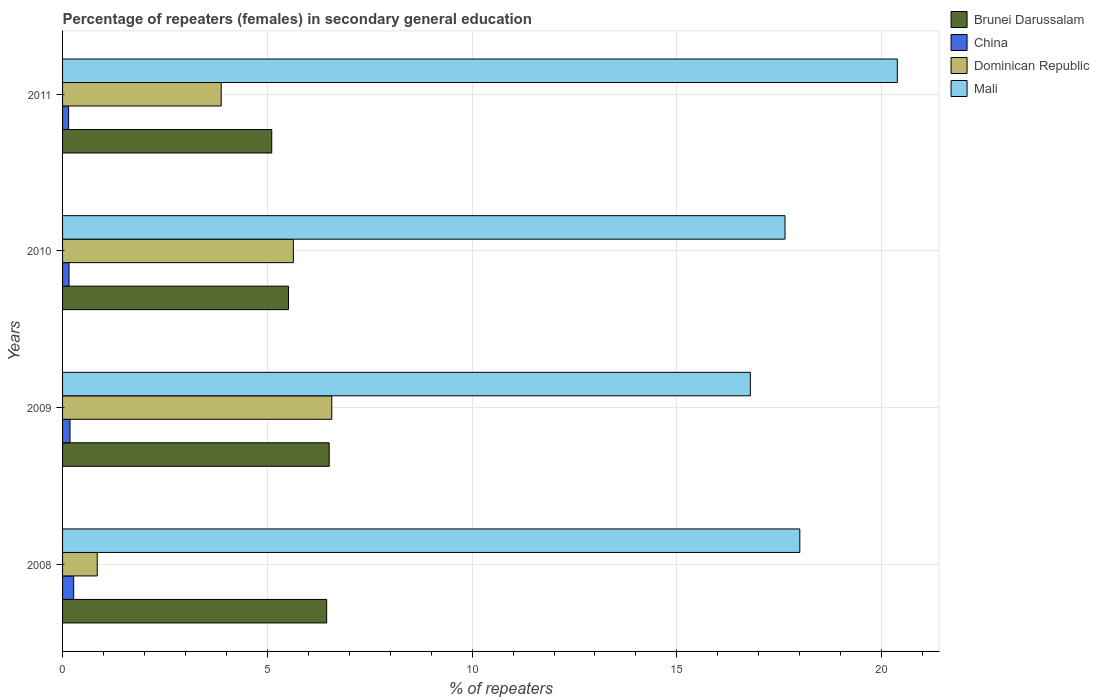How many groups of bars are there?
Your answer should be very brief. 4. What is the label of the 1st group of bars from the top?
Keep it short and to the point. 2011. What is the percentage of female repeaters in Brunei Darussalam in 2010?
Ensure brevity in your answer.  5.52. Across all years, what is the maximum percentage of female repeaters in Brunei Darussalam?
Your answer should be compact. 6.51. Across all years, what is the minimum percentage of female repeaters in Mali?
Your answer should be very brief. 16.79. In which year was the percentage of female repeaters in Dominican Republic maximum?
Your response must be concise. 2009. What is the total percentage of female repeaters in Brunei Darussalam in the graph?
Make the answer very short. 23.58. What is the difference between the percentage of female repeaters in Dominican Republic in 2008 and that in 2011?
Your answer should be very brief. -3.03. What is the difference between the percentage of female repeaters in Mali in 2009 and the percentage of female repeaters in Brunei Darussalam in 2011?
Give a very brief answer. 11.69. What is the average percentage of female repeaters in Dominican Republic per year?
Keep it short and to the point. 4.23. In the year 2011, what is the difference between the percentage of female repeaters in Dominican Republic and percentage of female repeaters in China?
Provide a short and direct response. 3.73. In how many years, is the percentage of female repeaters in China greater than 3 %?
Provide a succinct answer. 0. What is the ratio of the percentage of female repeaters in Mali in 2008 to that in 2010?
Ensure brevity in your answer.  1.02. Is the percentage of female repeaters in China in 2008 less than that in 2009?
Give a very brief answer. No. What is the difference between the highest and the second highest percentage of female repeaters in China?
Give a very brief answer. 0.09. What is the difference between the highest and the lowest percentage of female repeaters in Mali?
Keep it short and to the point. 3.59. In how many years, is the percentage of female repeaters in Mali greater than the average percentage of female repeaters in Mali taken over all years?
Provide a succinct answer. 1. Is the sum of the percentage of female repeaters in Dominican Republic in 2008 and 2010 greater than the maximum percentage of female repeaters in Mali across all years?
Provide a succinct answer. No. Is it the case that in every year, the sum of the percentage of female repeaters in China and percentage of female repeaters in Mali is greater than the sum of percentage of female repeaters in Brunei Darussalam and percentage of female repeaters in Dominican Republic?
Your answer should be very brief. Yes. What does the 4th bar from the top in 2009 represents?
Ensure brevity in your answer.  Brunei Darussalam. What does the 1st bar from the bottom in 2009 represents?
Your answer should be compact. Brunei Darussalam. Is it the case that in every year, the sum of the percentage of female repeaters in Mali and percentage of female repeaters in Dominican Republic is greater than the percentage of female repeaters in Brunei Darussalam?
Your response must be concise. Yes. How many bars are there?
Offer a terse response. 16. Are all the bars in the graph horizontal?
Provide a short and direct response. Yes. Are the values on the major ticks of X-axis written in scientific E-notation?
Your response must be concise. No. Does the graph contain grids?
Offer a terse response. Yes. Where does the legend appear in the graph?
Your response must be concise. Top right. What is the title of the graph?
Give a very brief answer. Percentage of repeaters (females) in secondary general education. Does "Marshall Islands" appear as one of the legend labels in the graph?
Give a very brief answer. No. What is the label or title of the X-axis?
Give a very brief answer. % of repeaters. What is the label or title of the Y-axis?
Make the answer very short. Years. What is the % of repeaters in Brunei Darussalam in 2008?
Offer a very short reply. 6.45. What is the % of repeaters in China in 2008?
Make the answer very short. 0.27. What is the % of repeaters of Dominican Republic in 2008?
Your answer should be very brief. 0.85. What is the % of repeaters in Mali in 2008?
Make the answer very short. 18. What is the % of repeaters of Brunei Darussalam in 2009?
Offer a terse response. 6.51. What is the % of repeaters of China in 2009?
Keep it short and to the point. 0.18. What is the % of repeaters of Dominican Republic in 2009?
Provide a succinct answer. 6.57. What is the % of repeaters in Mali in 2009?
Provide a succinct answer. 16.79. What is the % of repeaters in Brunei Darussalam in 2010?
Ensure brevity in your answer.  5.52. What is the % of repeaters of China in 2010?
Make the answer very short. 0.16. What is the % of repeaters in Dominican Republic in 2010?
Make the answer very short. 5.64. What is the % of repeaters in Mali in 2010?
Offer a terse response. 17.64. What is the % of repeaters in Brunei Darussalam in 2011?
Provide a short and direct response. 5.11. What is the % of repeaters of China in 2011?
Ensure brevity in your answer.  0.15. What is the % of repeaters of Dominican Republic in 2011?
Your answer should be compact. 3.87. What is the % of repeaters in Mali in 2011?
Ensure brevity in your answer.  20.38. Across all years, what is the maximum % of repeaters in Brunei Darussalam?
Make the answer very short. 6.51. Across all years, what is the maximum % of repeaters of China?
Provide a succinct answer. 0.27. Across all years, what is the maximum % of repeaters in Dominican Republic?
Your answer should be compact. 6.57. Across all years, what is the maximum % of repeaters of Mali?
Your response must be concise. 20.38. Across all years, what is the minimum % of repeaters in Brunei Darussalam?
Offer a very short reply. 5.11. Across all years, what is the minimum % of repeaters in China?
Give a very brief answer. 0.15. Across all years, what is the minimum % of repeaters of Dominican Republic?
Offer a terse response. 0.85. Across all years, what is the minimum % of repeaters of Mali?
Offer a terse response. 16.79. What is the total % of repeaters in Brunei Darussalam in the graph?
Give a very brief answer. 23.58. What is the total % of repeaters in China in the graph?
Your answer should be compact. 0.76. What is the total % of repeaters of Dominican Republic in the graph?
Offer a terse response. 16.93. What is the total % of repeaters of Mali in the graph?
Your response must be concise. 72.82. What is the difference between the % of repeaters in Brunei Darussalam in 2008 and that in 2009?
Keep it short and to the point. -0.06. What is the difference between the % of repeaters of China in 2008 and that in 2009?
Keep it short and to the point. 0.09. What is the difference between the % of repeaters in Dominican Republic in 2008 and that in 2009?
Your response must be concise. -5.73. What is the difference between the % of repeaters of Mali in 2008 and that in 2009?
Provide a short and direct response. 1.21. What is the difference between the % of repeaters of Brunei Darussalam in 2008 and that in 2010?
Your answer should be very brief. 0.93. What is the difference between the % of repeaters of China in 2008 and that in 2010?
Give a very brief answer. 0.11. What is the difference between the % of repeaters in Dominican Republic in 2008 and that in 2010?
Give a very brief answer. -4.79. What is the difference between the % of repeaters of Mali in 2008 and that in 2010?
Keep it short and to the point. 0.36. What is the difference between the % of repeaters of Brunei Darussalam in 2008 and that in 2011?
Make the answer very short. 1.34. What is the difference between the % of repeaters in China in 2008 and that in 2011?
Provide a succinct answer. 0.12. What is the difference between the % of repeaters in Dominican Republic in 2008 and that in 2011?
Ensure brevity in your answer.  -3.03. What is the difference between the % of repeaters of Mali in 2008 and that in 2011?
Keep it short and to the point. -2.38. What is the difference between the % of repeaters in China in 2009 and that in 2010?
Your response must be concise. 0.02. What is the difference between the % of repeaters in Dominican Republic in 2009 and that in 2010?
Keep it short and to the point. 0.94. What is the difference between the % of repeaters of Mali in 2009 and that in 2010?
Give a very brief answer. -0.85. What is the difference between the % of repeaters of Brunei Darussalam in 2009 and that in 2011?
Provide a short and direct response. 1.4. What is the difference between the % of repeaters in China in 2009 and that in 2011?
Your answer should be very brief. 0.03. What is the difference between the % of repeaters in Dominican Republic in 2009 and that in 2011?
Offer a very short reply. 2.7. What is the difference between the % of repeaters in Mali in 2009 and that in 2011?
Your answer should be compact. -3.59. What is the difference between the % of repeaters in Brunei Darussalam in 2010 and that in 2011?
Make the answer very short. 0.41. What is the difference between the % of repeaters in China in 2010 and that in 2011?
Your answer should be very brief. 0.01. What is the difference between the % of repeaters of Dominican Republic in 2010 and that in 2011?
Make the answer very short. 1.76. What is the difference between the % of repeaters of Mali in 2010 and that in 2011?
Keep it short and to the point. -2.74. What is the difference between the % of repeaters of Brunei Darussalam in 2008 and the % of repeaters of China in 2009?
Ensure brevity in your answer.  6.27. What is the difference between the % of repeaters in Brunei Darussalam in 2008 and the % of repeaters in Dominican Republic in 2009?
Your response must be concise. -0.13. What is the difference between the % of repeaters in Brunei Darussalam in 2008 and the % of repeaters in Mali in 2009?
Ensure brevity in your answer.  -10.35. What is the difference between the % of repeaters of China in 2008 and the % of repeaters of Dominican Republic in 2009?
Provide a succinct answer. -6.3. What is the difference between the % of repeaters of China in 2008 and the % of repeaters of Mali in 2009?
Make the answer very short. -16.52. What is the difference between the % of repeaters of Dominican Republic in 2008 and the % of repeaters of Mali in 2009?
Provide a succinct answer. -15.95. What is the difference between the % of repeaters in Brunei Darussalam in 2008 and the % of repeaters in China in 2010?
Give a very brief answer. 6.29. What is the difference between the % of repeaters in Brunei Darussalam in 2008 and the % of repeaters in Dominican Republic in 2010?
Provide a short and direct response. 0.81. What is the difference between the % of repeaters of Brunei Darussalam in 2008 and the % of repeaters of Mali in 2010?
Give a very brief answer. -11.19. What is the difference between the % of repeaters in China in 2008 and the % of repeaters in Dominican Republic in 2010?
Offer a terse response. -5.36. What is the difference between the % of repeaters in China in 2008 and the % of repeaters in Mali in 2010?
Your answer should be compact. -17.37. What is the difference between the % of repeaters in Dominican Republic in 2008 and the % of repeaters in Mali in 2010?
Make the answer very short. -16.79. What is the difference between the % of repeaters of Brunei Darussalam in 2008 and the % of repeaters of China in 2011?
Give a very brief answer. 6.3. What is the difference between the % of repeaters of Brunei Darussalam in 2008 and the % of repeaters of Dominican Republic in 2011?
Offer a terse response. 2.58. What is the difference between the % of repeaters in Brunei Darussalam in 2008 and the % of repeaters in Mali in 2011?
Give a very brief answer. -13.93. What is the difference between the % of repeaters of China in 2008 and the % of repeaters of Dominican Republic in 2011?
Make the answer very short. -3.6. What is the difference between the % of repeaters in China in 2008 and the % of repeaters in Mali in 2011?
Offer a very short reply. -20.11. What is the difference between the % of repeaters of Dominican Republic in 2008 and the % of repeaters of Mali in 2011?
Your answer should be very brief. -19.54. What is the difference between the % of repeaters in Brunei Darussalam in 2009 and the % of repeaters in China in 2010?
Provide a succinct answer. 6.35. What is the difference between the % of repeaters in Brunei Darussalam in 2009 and the % of repeaters in Dominican Republic in 2010?
Keep it short and to the point. 0.88. What is the difference between the % of repeaters in Brunei Darussalam in 2009 and the % of repeaters in Mali in 2010?
Your response must be concise. -11.13. What is the difference between the % of repeaters of China in 2009 and the % of repeaters of Dominican Republic in 2010?
Give a very brief answer. -5.45. What is the difference between the % of repeaters in China in 2009 and the % of repeaters in Mali in 2010?
Provide a succinct answer. -17.46. What is the difference between the % of repeaters in Dominican Republic in 2009 and the % of repeaters in Mali in 2010?
Offer a very short reply. -11.07. What is the difference between the % of repeaters in Brunei Darussalam in 2009 and the % of repeaters in China in 2011?
Make the answer very short. 6.36. What is the difference between the % of repeaters of Brunei Darussalam in 2009 and the % of repeaters of Dominican Republic in 2011?
Offer a terse response. 2.64. What is the difference between the % of repeaters in Brunei Darussalam in 2009 and the % of repeaters in Mali in 2011?
Provide a short and direct response. -13.87. What is the difference between the % of repeaters of China in 2009 and the % of repeaters of Dominican Republic in 2011?
Offer a terse response. -3.69. What is the difference between the % of repeaters in China in 2009 and the % of repeaters in Mali in 2011?
Make the answer very short. -20.2. What is the difference between the % of repeaters of Dominican Republic in 2009 and the % of repeaters of Mali in 2011?
Ensure brevity in your answer.  -13.81. What is the difference between the % of repeaters of Brunei Darussalam in 2010 and the % of repeaters of China in 2011?
Provide a short and direct response. 5.37. What is the difference between the % of repeaters of Brunei Darussalam in 2010 and the % of repeaters of Dominican Republic in 2011?
Ensure brevity in your answer.  1.64. What is the difference between the % of repeaters of Brunei Darussalam in 2010 and the % of repeaters of Mali in 2011?
Your answer should be compact. -14.87. What is the difference between the % of repeaters in China in 2010 and the % of repeaters in Dominican Republic in 2011?
Offer a terse response. -3.72. What is the difference between the % of repeaters of China in 2010 and the % of repeaters of Mali in 2011?
Your answer should be very brief. -20.22. What is the difference between the % of repeaters of Dominican Republic in 2010 and the % of repeaters of Mali in 2011?
Provide a succinct answer. -14.75. What is the average % of repeaters of Brunei Darussalam per year?
Your response must be concise. 5.9. What is the average % of repeaters of China per year?
Ensure brevity in your answer.  0.19. What is the average % of repeaters in Dominican Republic per year?
Make the answer very short. 4.23. What is the average % of repeaters in Mali per year?
Offer a very short reply. 18.2. In the year 2008, what is the difference between the % of repeaters of Brunei Darussalam and % of repeaters of China?
Make the answer very short. 6.18. In the year 2008, what is the difference between the % of repeaters of Brunei Darussalam and % of repeaters of Dominican Republic?
Provide a short and direct response. 5.6. In the year 2008, what is the difference between the % of repeaters of Brunei Darussalam and % of repeaters of Mali?
Offer a terse response. -11.55. In the year 2008, what is the difference between the % of repeaters in China and % of repeaters in Dominican Republic?
Your response must be concise. -0.58. In the year 2008, what is the difference between the % of repeaters of China and % of repeaters of Mali?
Your answer should be compact. -17.73. In the year 2008, what is the difference between the % of repeaters of Dominican Republic and % of repeaters of Mali?
Ensure brevity in your answer.  -17.16. In the year 2009, what is the difference between the % of repeaters of Brunei Darussalam and % of repeaters of China?
Your response must be concise. 6.33. In the year 2009, what is the difference between the % of repeaters in Brunei Darussalam and % of repeaters in Dominican Republic?
Offer a terse response. -0.06. In the year 2009, what is the difference between the % of repeaters in Brunei Darussalam and % of repeaters in Mali?
Provide a short and direct response. -10.28. In the year 2009, what is the difference between the % of repeaters in China and % of repeaters in Dominican Republic?
Your answer should be compact. -6.39. In the year 2009, what is the difference between the % of repeaters of China and % of repeaters of Mali?
Provide a succinct answer. -16.61. In the year 2009, what is the difference between the % of repeaters of Dominican Republic and % of repeaters of Mali?
Your answer should be compact. -10.22. In the year 2010, what is the difference between the % of repeaters of Brunei Darussalam and % of repeaters of China?
Give a very brief answer. 5.36. In the year 2010, what is the difference between the % of repeaters of Brunei Darussalam and % of repeaters of Dominican Republic?
Your answer should be very brief. -0.12. In the year 2010, what is the difference between the % of repeaters in Brunei Darussalam and % of repeaters in Mali?
Your response must be concise. -12.12. In the year 2010, what is the difference between the % of repeaters of China and % of repeaters of Dominican Republic?
Your answer should be compact. -5.48. In the year 2010, what is the difference between the % of repeaters of China and % of repeaters of Mali?
Offer a terse response. -17.48. In the year 2010, what is the difference between the % of repeaters in Dominican Republic and % of repeaters in Mali?
Make the answer very short. -12. In the year 2011, what is the difference between the % of repeaters in Brunei Darussalam and % of repeaters in China?
Provide a succinct answer. 4.96. In the year 2011, what is the difference between the % of repeaters of Brunei Darussalam and % of repeaters of Dominican Republic?
Keep it short and to the point. 1.23. In the year 2011, what is the difference between the % of repeaters of Brunei Darussalam and % of repeaters of Mali?
Provide a succinct answer. -15.28. In the year 2011, what is the difference between the % of repeaters of China and % of repeaters of Dominican Republic?
Make the answer very short. -3.73. In the year 2011, what is the difference between the % of repeaters in China and % of repeaters in Mali?
Provide a short and direct response. -20.23. In the year 2011, what is the difference between the % of repeaters in Dominican Republic and % of repeaters in Mali?
Your answer should be compact. -16.51. What is the ratio of the % of repeaters of China in 2008 to that in 2009?
Keep it short and to the point. 1.49. What is the ratio of the % of repeaters in Dominican Republic in 2008 to that in 2009?
Your response must be concise. 0.13. What is the ratio of the % of repeaters of Mali in 2008 to that in 2009?
Ensure brevity in your answer.  1.07. What is the ratio of the % of repeaters in Brunei Darussalam in 2008 to that in 2010?
Provide a short and direct response. 1.17. What is the ratio of the % of repeaters in China in 2008 to that in 2010?
Your answer should be compact. 1.72. What is the ratio of the % of repeaters in Dominican Republic in 2008 to that in 2010?
Provide a succinct answer. 0.15. What is the ratio of the % of repeaters in Mali in 2008 to that in 2010?
Your answer should be compact. 1.02. What is the ratio of the % of repeaters of Brunei Darussalam in 2008 to that in 2011?
Give a very brief answer. 1.26. What is the ratio of the % of repeaters of China in 2008 to that in 2011?
Offer a terse response. 1.84. What is the ratio of the % of repeaters in Dominican Republic in 2008 to that in 2011?
Keep it short and to the point. 0.22. What is the ratio of the % of repeaters of Mali in 2008 to that in 2011?
Ensure brevity in your answer.  0.88. What is the ratio of the % of repeaters in Brunei Darussalam in 2009 to that in 2010?
Keep it short and to the point. 1.18. What is the ratio of the % of repeaters in China in 2009 to that in 2010?
Your answer should be very brief. 1.15. What is the ratio of the % of repeaters in Dominican Republic in 2009 to that in 2010?
Your response must be concise. 1.17. What is the ratio of the % of repeaters in Brunei Darussalam in 2009 to that in 2011?
Keep it short and to the point. 1.27. What is the ratio of the % of repeaters of China in 2009 to that in 2011?
Your answer should be compact. 1.23. What is the ratio of the % of repeaters in Dominican Republic in 2009 to that in 2011?
Give a very brief answer. 1.7. What is the ratio of the % of repeaters in Mali in 2009 to that in 2011?
Offer a terse response. 0.82. What is the ratio of the % of repeaters in Brunei Darussalam in 2010 to that in 2011?
Provide a short and direct response. 1.08. What is the ratio of the % of repeaters in China in 2010 to that in 2011?
Your answer should be very brief. 1.07. What is the ratio of the % of repeaters in Dominican Republic in 2010 to that in 2011?
Provide a succinct answer. 1.46. What is the ratio of the % of repeaters in Mali in 2010 to that in 2011?
Make the answer very short. 0.87. What is the difference between the highest and the second highest % of repeaters of Brunei Darussalam?
Make the answer very short. 0.06. What is the difference between the highest and the second highest % of repeaters of China?
Your answer should be very brief. 0.09. What is the difference between the highest and the second highest % of repeaters of Dominican Republic?
Offer a very short reply. 0.94. What is the difference between the highest and the second highest % of repeaters in Mali?
Your answer should be very brief. 2.38. What is the difference between the highest and the lowest % of repeaters in Brunei Darussalam?
Your answer should be very brief. 1.4. What is the difference between the highest and the lowest % of repeaters in China?
Offer a terse response. 0.12. What is the difference between the highest and the lowest % of repeaters in Dominican Republic?
Make the answer very short. 5.73. What is the difference between the highest and the lowest % of repeaters of Mali?
Your answer should be very brief. 3.59. 